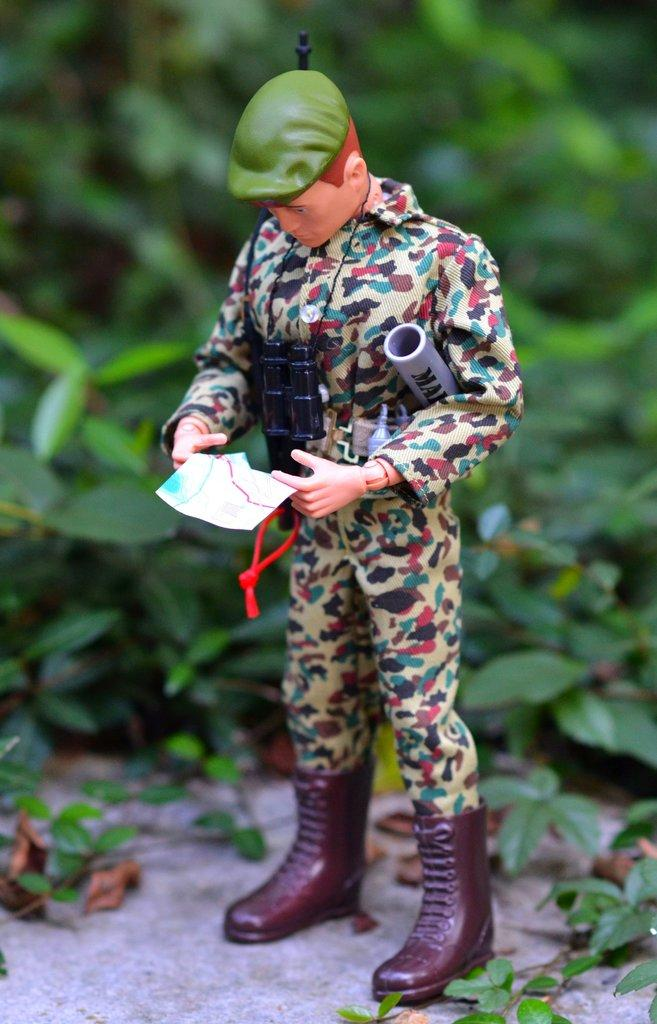What object is in the front of the image? There is a toy in the front of the image. What can be seen in the background of the image? There are leaves in the background of the image. What type of club is visible in the image? There is no club present in the image; it features a toy in the front and leaves in the background. 